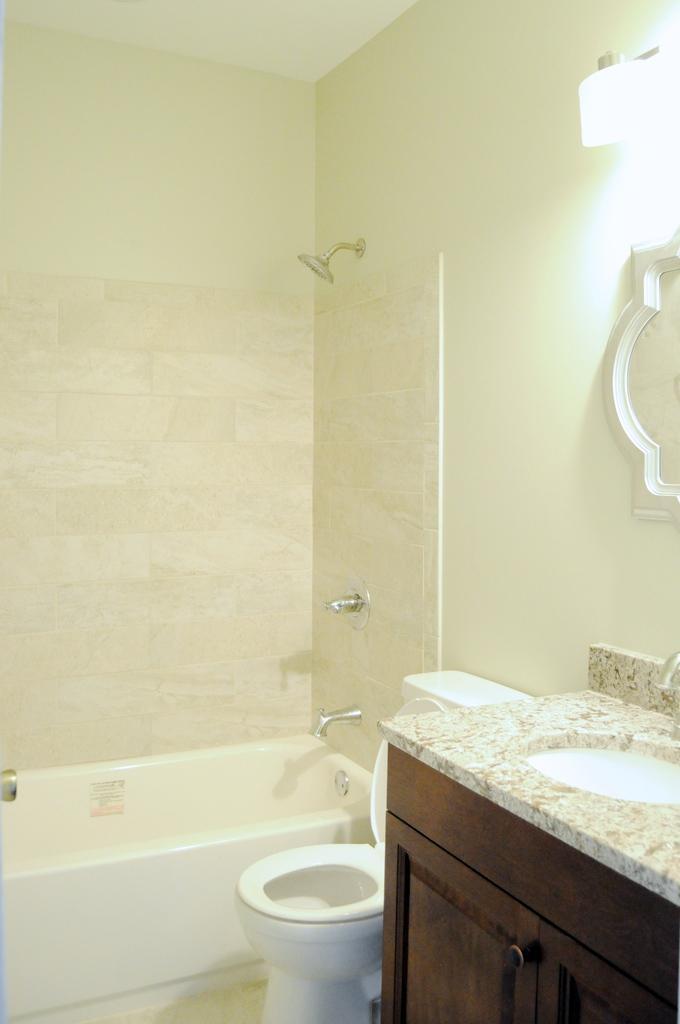In one or two sentences, can you explain what this image depicts? In this image, we can see the interior view of a bathroom. We can also see the wall with some objects. We can also see a bathtub and a white colored object. We can see a table with the sink. We can see the mirror. 